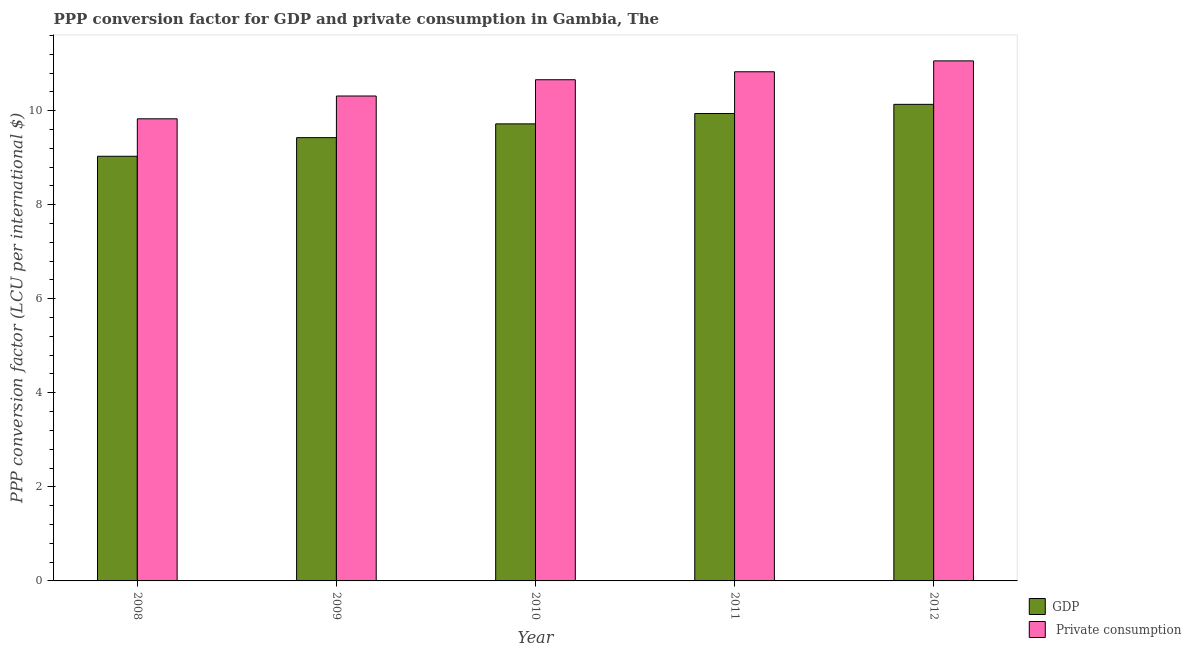How many groups of bars are there?
Ensure brevity in your answer.  5. Are the number of bars per tick equal to the number of legend labels?
Keep it short and to the point. Yes. Are the number of bars on each tick of the X-axis equal?
Provide a short and direct response. Yes. How many bars are there on the 3rd tick from the left?
Provide a short and direct response. 2. How many bars are there on the 5th tick from the right?
Your answer should be very brief. 2. What is the ppp conversion factor for private consumption in 2008?
Offer a terse response. 9.83. Across all years, what is the maximum ppp conversion factor for gdp?
Provide a succinct answer. 10.13. Across all years, what is the minimum ppp conversion factor for gdp?
Your response must be concise. 9.03. What is the total ppp conversion factor for private consumption in the graph?
Provide a succinct answer. 52.68. What is the difference between the ppp conversion factor for gdp in 2009 and that in 2011?
Your response must be concise. -0.51. What is the difference between the ppp conversion factor for private consumption in 2012 and the ppp conversion factor for gdp in 2011?
Keep it short and to the point. 0.23. What is the average ppp conversion factor for gdp per year?
Keep it short and to the point. 9.65. What is the ratio of the ppp conversion factor for private consumption in 2011 to that in 2012?
Provide a short and direct response. 0.98. Is the ppp conversion factor for gdp in 2008 less than that in 2011?
Provide a succinct answer. Yes. Is the difference between the ppp conversion factor for private consumption in 2008 and 2011 greater than the difference between the ppp conversion factor for gdp in 2008 and 2011?
Make the answer very short. No. What is the difference between the highest and the second highest ppp conversion factor for gdp?
Ensure brevity in your answer.  0.2. What is the difference between the highest and the lowest ppp conversion factor for private consumption?
Offer a very short reply. 1.23. In how many years, is the ppp conversion factor for private consumption greater than the average ppp conversion factor for private consumption taken over all years?
Give a very brief answer. 3. What does the 2nd bar from the left in 2012 represents?
Give a very brief answer.  Private consumption. What does the 2nd bar from the right in 2011 represents?
Keep it short and to the point. GDP. Are all the bars in the graph horizontal?
Ensure brevity in your answer.  No. What is the difference between two consecutive major ticks on the Y-axis?
Offer a terse response. 2. Does the graph contain any zero values?
Provide a short and direct response. No. How are the legend labels stacked?
Offer a very short reply. Vertical. What is the title of the graph?
Provide a succinct answer. PPP conversion factor for GDP and private consumption in Gambia, The. Does "Investment in Telecom" appear as one of the legend labels in the graph?
Your answer should be compact. No. What is the label or title of the Y-axis?
Offer a very short reply. PPP conversion factor (LCU per international $). What is the PPP conversion factor (LCU per international $) of GDP in 2008?
Your answer should be compact. 9.03. What is the PPP conversion factor (LCU per international $) in  Private consumption in 2008?
Offer a very short reply. 9.83. What is the PPP conversion factor (LCU per international $) of GDP in 2009?
Provide a short and direct response. 9.43. What is the PPP conversion factor (LCU per international $) of  Private consumption in 2009?
Provide a succinct answer. 10.31. What is the PPP conversion factor (LCU per international $) of GDP in 2010?
Offer a terse response. 9.72. What is the PPP conversion factor (LCU per international $) of  Private consumption in 2010?
Your answer should be very brief. 10.66. What is the PPP conversion factor (LCU per international $) in GDP in 2011?
Offer a terse response. 9.94. What is the PPP conversion factor (LCU per international $) in  Private consumption in 2011?
Provide a succinct answer. 10.83. What is the PPP conversion factor (LCU per international $) in GDP in 2012?
Offer a terse response. 10.13. What is the PPP conversion factor (LCU per international $) in  Private consumption in 2012?
Offer a terse response. 11.06. Across all years, what is the maximum PPP conversion factor (LCU per international $) in GDP?
Offer a very short reply. 10.13. Across all years, what is the maximum PPP conversion factor (LCU per international $) in  Private consumption?
Ensure brevity in your answer.  11.06. Across all years, what is the minimum PPP conversion factor (LCU per international $) of GDP?
Offer a very short reply. 9.03. Across all years, what is the minimum PPP conversion factor (LCU per international $) in  Private consumption?
Provide a short and direct response. 9.83. What is the total PPP conversion factor (LCU per international $) in GDP in the graph?
Offer a terse response. 48.25. What is the total PPP conversion factor (LCU per international $) of  Private consumption in the graph?
Offer a terse response. 52.68. What is the difference between the PPP conversion factor (LCU per international $) of GDP in 2008 and that in 2009?
Ensure brevity in your answer.  -0.4. What is the difference between the PPP conversion factor (LCU per international $) of  Private consumption in 2008 and that in 2009?
Give a very brief answer. -0.48. What is the difference between the PPP conversion factor (LCU per international $) in GDP in 2008 and that in 2010?
Provide a short and direct response. -0.69. What is the difference between the PPP conversion factor (LCU per international $) of  Private consumption in 2008 and that in 2010?
Offer a terse response. -0.83. What is the difference between the PPP conversion factor (LCU per international $) in GDP in 2008 and that in 2011?
Offer a very short reply. -0.91. What is the difference between the PPP conversion factor (LCU per international $) in  Private consumption in 2008 and that in 2011?
Make the answer very short. -1. What is the difference between the PPP conversion factor (LCU per international $) in GDP in 2008 and that in 2012?
Provide a short and direct response. -1.1. What is the difference between the PPP conversion factor (LCU per international $) of  Private consumption in 2008 and that in 2012?
Your answer should be compact. -1.23. What is the difference between the PPP conversion factor (LCU per international $) in GDP in 2009 and that in 2010?
Your answer should be compact. -0.29. What is the difference between the PPP conversion factor (LCU per international $) of  Private consumption in 2009 and that in 2010?
Your answer should be very brief. -0.35. What is the difference between the PPP conversion factor (LCU per international $) of GDP in 2009 and that in 2011?
Your answer should be very brief. -0.51. What is the difference between the PPP conversion factor (LCU per international $) in  Private consumption in 2009 and that in 2011?
Your answer should be very brief. -0.52. What is the difference between the PPP conversion factor (LCU per international $) of GDP in 2009 and that in 2012?
Make the answer very short. -0.71. What is the difference between the PPP conversion factor (LCU per international $) of  Private consumption in 2009 and that in 2012?
Offer a terse response. -0.75. What is the difference between the PPP conversion factor (LCU per international $) of GDP in 2010 and that in 2011?
Ensure brevity in your answer.  -0.22. What is the difference between the PPP conversion factor (LCU per international $) of  Private consumption in 2010 and that in 2011?
Make the answer very short. -0.17. What is the difference between the PPP conversion factor (LCU per international $) in GDP in 2010 and that in 2012?
Your answer should be very brief. -0.41. What is the difference between the PPP conversion factor (LCU per international $) of  Private consumption in 2010 and that in 2012?
Make the answer very short. -0.4. What is the difference between the PPP conversion factor (LCU per international $) of GDP in 2011 and that in 2012?
Ensure brevity in your answer.  -0.2. What is the difference between the PPP conversion factor (LCU per international $) in  Private consumption in 2011 and that in 2012?
Offer a terse response. -0.23. What is the difference between the PPP conversion factor (LCU per international $) of GDP in 2008 and the PPP conversion factor (LCU per international $) of  Private consumption in 2009?
Provide a succinct answer. -1.28. What is the difference between the PPP conversion factor (LCU per international $) in GDP in 2008 and the PPP conversion factor (LCU per international $) in  Private consumption in 2010?
Keep it short and to the point. -1.63. What is the difference between the PPP conversion factor (LCU per international $) in GDP in 2008 and the PPP conversion factor (LCU per international $) in  Private consumption in 2011?
Your response must be concise. -1.8. What is the difference between the PPP conversion factor (LCU per international $) in GDP in 2008 and the PPP conversion factor (LCU per international $) in  Private consumption in 2012?
Keep it short and to the point. -2.03. What is the difference between the PPP conversion factor (LCU per international $) in GDP in 2009 and the PPP conversion factor (LCU per international $) in  Private consumption in 2010?
Provide a succinct answer. -1.23. What is the difference between the PPP conversion factor (LCU per international $) of GDP in 2009 and the PPP conversion factor (LCU per international $) of  Private consumption in 2011?
Provide a short and direct response. -1.4. What is the difference between the PPP conversion factor (LCU per international $) in GDP in 2009 and the PPP conversion factor (LCU per international $) in  Private consumption in 2012?
Ensure brevity in your answer.  -1.63. What is the difference between the PPP conversion factor (LCU per international $) of GDP in 2010 and the PPP conversion factor (LCU per international $) of  Private consumption in 2011?
Keep it short and to the point. -1.11. What is the difference between the PPP conversion factor (LCU per international $) in GDP in 2010 and the PPP conversion factor (LCU per international $) in  Private consumption in 2012?
Make the answer very short. -1.34. What is the difference between the PPP conversion factor (LCU per international $) of GDP in 2011 and the PPP conversion factor (LCU per international $) of  Private consumption in 2012?
Offer a very short reply. -1.12. What is the average PPP conversion factor (LCU per international $) of GDP per year?
Your response must be concise. 9.65. What is the average PPP conversion factor (LCU per international $) in  Private consumption per year?
Provide a succinct answer. 10.54. In the year 2008, what is the difference between the PPP conversion factor (LCU per international $) in GDP and PPP conversion factor (LCU per international $) in  Private consumption?
Give a very brief answer. -0.8. In the year 2009, what is the difference between the PPP conversion factor (LCU per international $) in GDP and PPP conversion factor (LCU per international $) in  Private consumption?
Your answer should be very brief. -0.89. In the year 2010, what is the difference between the PPP conversion factor (LCU per international $) of GDP and PPP conversion factor (LCU per international $) of  Private consumption?
Your answer should be compact. -0.94. In the year 2011, what is the difference between the PPP conversion factor (LCU per international $) in GDP and PPP conversion factor (LCU per international $) in  Private consumption?
Your response must be concise. -0.89. In the year 2012, what is the difference between the PPP conversion factor (LCU per international $) of GDP and PPP conversion factor (LCU per international $) of  Private consumption?
Your response must be concise. -0.92. What is the ratio of the PPP conversion factor (LCU per international $) in GDP in 2008 to that in 2009?
Your answer should be compact. 0.96. What is the ratio of the PPP conversion factor (LCU per international $) in  Private consumption in 2008 to that in 2009?
Provide a short and direct response. 0.95. What is the ratio of the PPP conversion factor (LCU per international $) in GDP in 2008 to that in 2010?
Ensure brevity in your answer.  0.93. What is the ratio of the PPP conversion factor (LCU per international $) in  Private consumption in 2008 to that in 2010?
Keep it short and to the point. 0.92. What is the ratio of the PPP conversion factor (LCU per international $) in GDP in 2008 to that in 2011?
Make the answer very short. 0.91. What is the ratio of the PPP conversion factor (LCU per international $) in  Private consumption in 2008 to that in 2011?
Offer a terse response. 0.91. What is the ratio of the PPP conversion factor (LCU per international $) of GDP in 2008 to that in 2012?
Offer a terse response. 0.89. What is the ratio of the PPP conversion factor (LCU per international $) in  Private consumption in 2008 to that in 2012?
Ensure brevity in your answer.  0.89. What is the ratio of the PPP conversion factor (LCU per international $) of GDP in 2009 to that in 2010?
Provide a succinct answer. 0.97. What is the ratio of the PPP conversion factor (LCU per international $) of  Private consumption in 2009 to that in 2010?
Offer a terse response. 0.97. What is the ratio of the PPP conversion factor (LCU per international $) of GDP in 2009 to that in 2011?
Offer a very short reply. 0.95. What is the ratio of the PPP conversion factor (LCU per international $) in  Private consumption in 2009 to that in 2011?
Make the answer very short. 0.95. What is the ratio of the PPP conversion factor (LCU per international $) of GDP in 2009 to that in 2012?
Keep it short and to the point. 0.93. What is the ratio of the PPP conversion factor (LCU per international $) in  Private consumption in 2009 to that in 2012?
Make the answer very short. 0.93. What is the ratio of the PPP conversion factor (LCU per international $) in GDP in 2010 to that in 2011?
Ensure brevity in your answer.  0.98. What is the ratio of the PPP conversion factor (LCU per international $) in  Private consumption in 2010 to that in 2011?
Provide a short and direct response. 0.98. What is the ratio of the PPP conversion factor (LCU per international $) of  Private consumption in 2010 to that in 2012?
Your answer should be very brief. 0.96. What is the ratio of the PPP conversion factor (LCU per international $) of GDP in 2011 to that in 2012?
Provide a short and direct response. 0.98. What is the difference between the highest and the second highest PPP conversion factor (LCU per international $) in GDP?
Keep it short and to the point. 0.2. What is the difference between the highest and the second highest PPP conversion factor (LCU per international $) in  Private consumption?
Your response must be concise. 0.23. What is the difference between the highest and the lowest PPP conversion factor (LCU per international $) in GDP?
Provide a short and direct response. 1.1. What is the difference between the highest and the lowest PPP conversion factor (LCU per international $) in  Private consumption?
Your answer should be very brief. 1.23. 